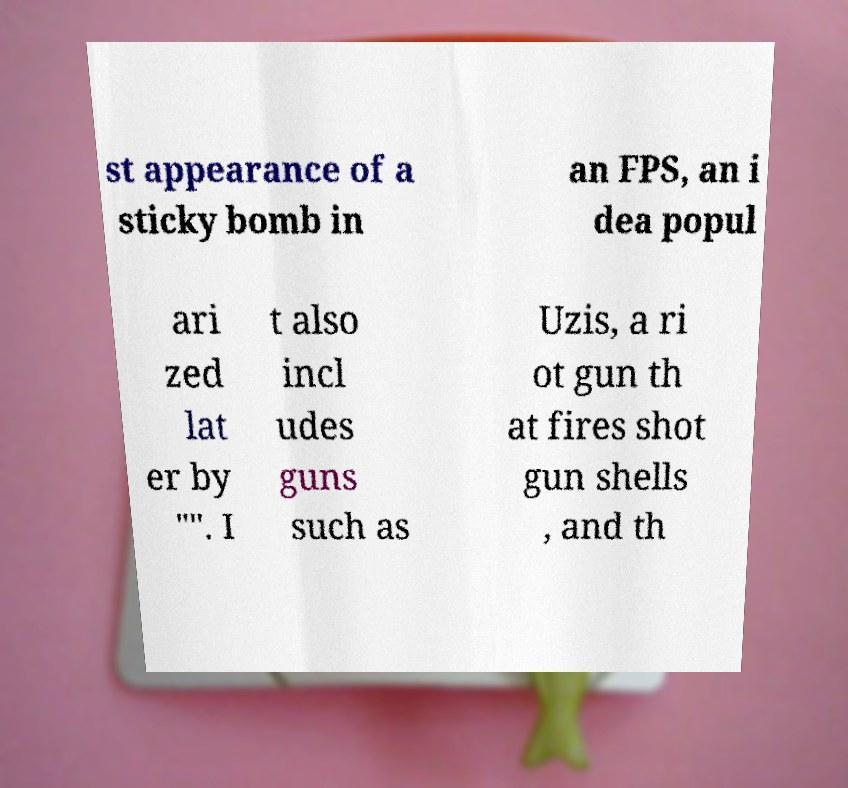Could you assist in decoding the text presented in this image and type it out clearly? st appearance of a sticky bomb in an FPS, an i dea popul ari zed lat er by "". I t also incl udes guns such as Uzis, a ri ot gun th at fires shot gun shells , and th 